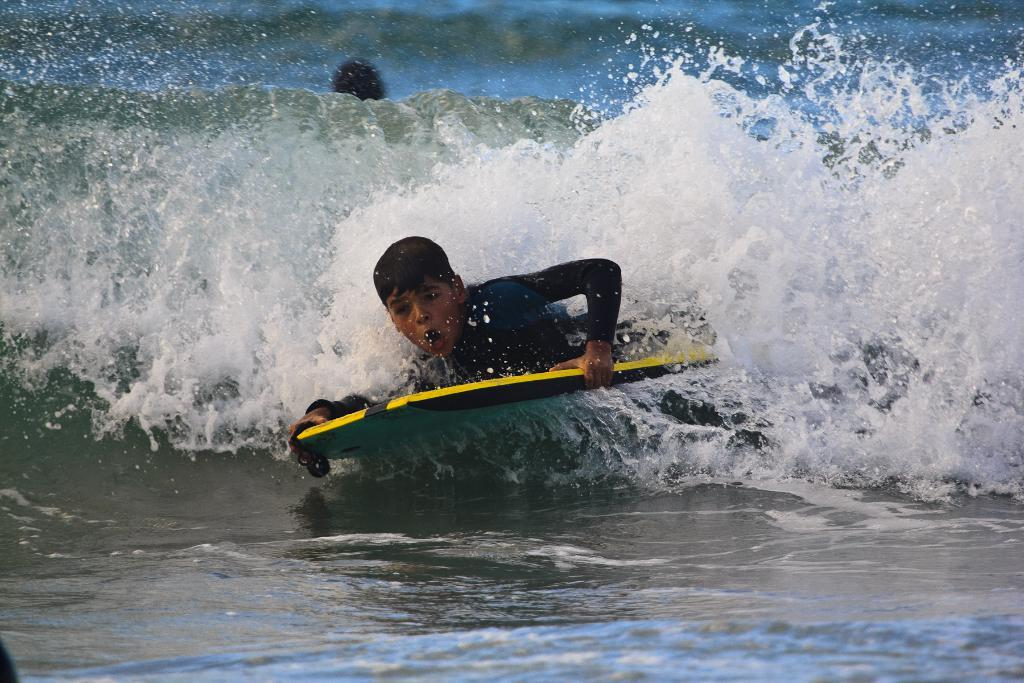Where was the image taken? The image was taken outdoors. What is the boy holding in the image? The boy is holding a board in the image. What activity is the boy engaged in? The boy is surfing on water in the image. Can you describe the other person in the image? There is another person behind the boy in the image. What type of nest can be seen in the image? There is no nest present in the image. 